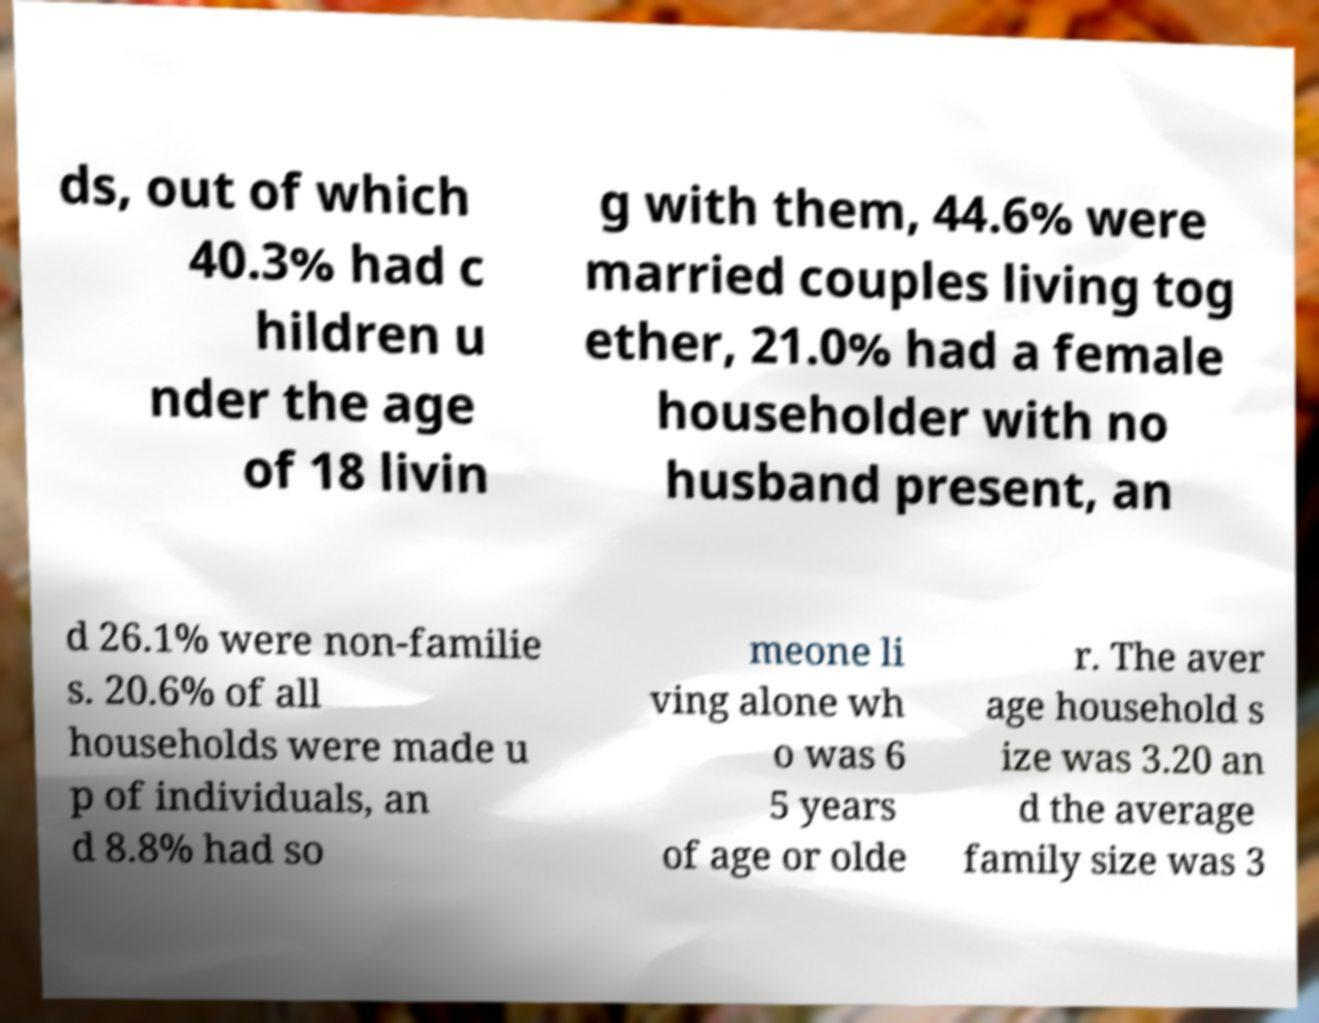For documentation purposes, I need the text within this image transcribed. Could you provide that? ds, out of which 40.3% had c hildren u nder the age of 18 livin g with them, 44.6% were married couples living tog ether, 21.0% had a female householder with no husband present, an d 26.1% were non-familie s. 20.6% of all households were made u p of individuals, an d 8.8% had so meone li ving alone wh o was 6 5 years of age or olde r. The aver age household s ize was 3.20 an d the average family size was 3 